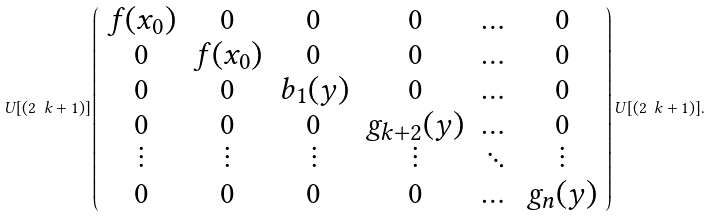Convert formula to latex. <formula><loc_0><loc_0><loc_500><loc_500>U [ ( 2 \ k + 1 ) ] \left ( \begin{array} { c c c c c c } f ( x _ { 0 } ) & 0 & 0 & 0 & \dots & 0 \\ 0 & f ( x _ { 0 } ) & 0 & 0 & \dots & 0 \\ 0 & 0 & b _ { 1 } ( y ) & 0 & \dots & 0 \\ 0 & 0 & 0 & g _ { k + 2 } ( y ) & \dots & 0 \\ \vdots & \vdots & \vdots & \vdots & \ddots & \vdots \\ 0 & 0 & 0 & 0 & \dots & g _ { n } ( y ) \end{array} \right ) U [ ( 2 \ k + 1 ) ] .</formula> 